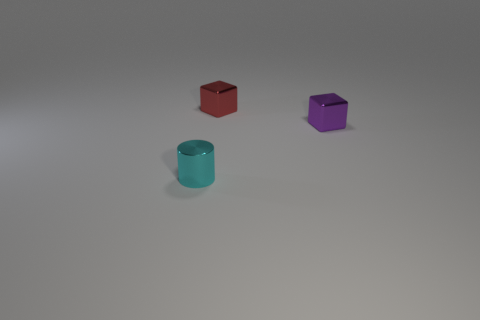Add 1 purple things. How many objects exist? 4 Subtract all blocks. How many objects are left? 1 Add 3 purple metal blocks. How many purple metal blocks are left? 4 Add 1 small shiny blocks. How many small shiny blocks exist? 3 Subtract 0 purple spheres. How many objects are left? 3 Subtract all small cyan rubber objects. Subtract all tiny red metal objects. How many objects are left? 2 